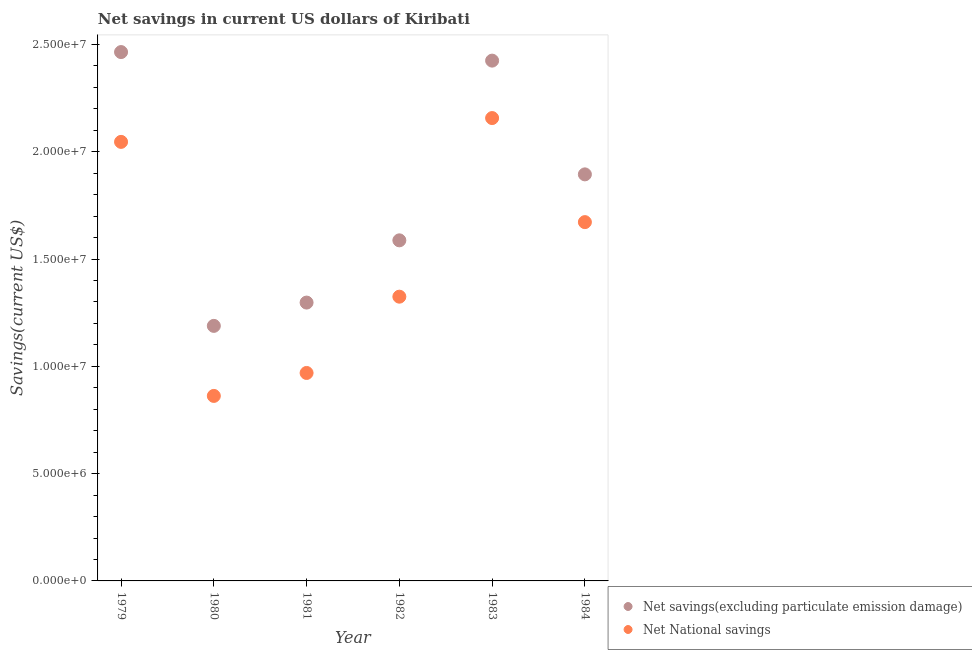What is the net savings(excluding particulate emission damage) in 1981?
Ensure brevity in your answer.  1.30e+07. Across all years, what is the maximum net national savings?
Your answer should be compact. 2.16e+07. Across all years, what is the minimum net national savings?
Ensure brevity in your answer.  8.62e+06. In which year was the net savings(excluding particulate emission damage) maximum?
Your answer should be compact. 1979. In which year was the net savings(excluding particulate emission damage) minimum?
Provide a short and direct response. 1980. What is the total net national savings in the graph?
Keep it short and to the point. 9.03e+07. What is the difference between the net national savings in 1980 and that in 1983?
Keep it short and to the point. -1.29e+07. What is the difference between the net national savings in 1982 and the net savings(excluding particulate emission damage) in 1979?
Ensure brevity in your answer.  -1.14e+07. What is the average net national savings per year?
Give a very brief answer. 1.51e+07. In the year 1982, what is the difference between the net national savings and net savings(excluding particulate emission damage)?
Ensure brevity in your answer.  -2.63e+06. In how many years, is the net national savings greater than 8000000 US$?
Your answer should be compact. 6. What is the ratio of the net national savings in 1982 to that in 1984?
Your response must be concise. 0.79. Is the net savings(excluding particulate emission damage) in 1982 less than that in 1983?
Provide a succinct answer. Yes. Is the difference between the net savings(excluding particulate emission damage) in 1979 and 1980 greater than the difference between the net national savings in 1979 and 1980?
Your answer should be very brief. Yes. What is the difference between the highest and the second highest net savings(excluding particulate emission damage)?
Offer a very short reply. 3.99e+05. What is the difference between the highest and the lowest net savings(excluding particulate emission damage)?
Your answer should be compact. 1.28e+07. In how many years, is the net savings(excluding particulate emission damage) greater than the average net savings(excluding particulate emission damage) taken over all years?
Give a very brief answer. 3. Does the net national savings monotonically increase over the years?
Your response must be concise. No. Is the net national savings strictly greater than the net savings(excluding particulate emission damage) over the years?
Offer a very short reply. No. Is the net national savings strictly less than the net savings(excluding particulate emission damage) over the years?
Provide a succinct answer. Yes. How many dotlines are there?
Offer a very short reply. 2. How many years are there in the graph?
Provide a short and direct response. 6. What is the difference between two consecutive major ticks on the Y-axis?
Keep it short and to the point. 5.00e+06. Does the graph contain any zero values?
Ensure brevity in your answer.  No. Where does the legend appear in the graph?
Ensure brevity in your answer.  Bottom right. How many legend labels are there?
Your response must be concise. 2. How are the legend labels stacked?
Provide a short and direct response. Vertical. What is the title of the graph?
Your response must be concise. Net savings in current US dollars of Kiribati. Does "Crop" appear as one of the legend labels in the graph?
Keep it short and to the point. No. What is the label or title of the Y-axis?
Provide a succinct answer. Savings(current US$). What is the Savings(current US$) in Net savings(excluding particulate emission damage) in 1979?
Offer a terse response. 2.46e+07. What is the Savings(current US$) in Net National savings in 1979?
Give a very brief answer. 2.05e+07. What is the Savings(current US$) in Net savings(excluding particulate emission damage) in 1980?
Make the answer very short. 1.19e+07. What is the Savings(current US$) of Net National savings in 1980?
Ensure brevity in your answer.  8.62e+06. What is the Savings(current US$) in Net savings(excluding particulate emission damage) in 1981?
Your answer should be very brief. 1.30e+07. What is the Savings(current US$) of Net National savings in 1981?
Provide a short and direct response. 9.69e+06. What is the Savings(current US$) in Net savings(excluding particulate emission damage) in 1982?
Offer a very short reply. 1.59e+07. What is the Savings(current US$) of Net National savings in 1982?
Ensure brevity in your answer.  1.32e+07. What is the Savings(current US$) of Net savings(excluding particulate emission damage) in 1983?
Offer a very short reply. 2.42e+07. What is the Savings(current US$) in Net National savings in 1983?
Offer a very short reply. 2.16e+07. What is the Savings(current US$) in Net savings(excluding particulate emission damage) in 1984?
Make the answer very short. 1.89e+07. What is the Savings(current US$) in Net National savings in 1984?
Offer a very short reply. 1.67e+07. Across all years, what is the maximum Savings(current US$) of Net savings(excluding particulate emission damage)?
Offer a terse response. 2.46e+07. Across all years, what is the maximum Savings(current US$) of Net National savings?
Provide a succinct answer. 2.16e+07. Across all years, what is the minimum Savings(current US$) of Net savings(excluding particulate emission damage)?
Your answer should be compact. 1.19e+07. Across all years, what is the minimum Savings(current US$) in Net National savings?
Your answer should be very brief. 8.62e+06. What is the total Savings(current US$) in Net savings(excluding particulate emission damage) in the graph?
Offer a terse response. 1.09e+08. What is the total Savings(current US$) of Net National savings in the graph?
Ensure brevity in your answer.  9.03e+07. What is the difference between the Savings(current US$) in Net savings(excluding particulate emission damage) in 1979 and that in 1980?
Your answer should be very brief. 1.28e+07. What is the difference between the Savings(current US$) of Net National savings in 1979 and that in 1980?
Your answer should be compact. 1.18e+07. What is the difference between the Savings(current US$) in Net savings(excluding particulate emission damage) in 1979 and that in 1981?
Offer a very short reply. 1.17e+07. What is the difference between the Savings(current US$) in Net National savings in 1979 and that in 1981?
Ensure brevity in your answer.  1.08e+07. What is the difference between the Savings(current US$) in Net savings(excluding particulate emission damage) in 1979 and that in 1982?
Keep it short and to the point. 8.77e+06. What is the difference between the Savings(current US$) of Net National savings in 1979 and that in 1982?
Your answer should be very brief. 7.21e+06. What is the difference between the Savings(current US$) of Net savings(excluding particulate emission damage) in 1979 and that in 1983?
Make the answer very short. 3.99e+05. What is the difference between the Savings(current US$) in Net National savings in 1979 and that in 1983?
Your answer should be compact. -1.11e+06. What is the difference between the Savings(current US$) in Net savings(excluding particulate emission damage) in 1979 and that in 1984?
Ensure brevity in your answer.  5.70e+06. What is the difference between the Savings(current US$) of Net National savings in 1979 and that in 1984?
Your answer should be compact. 3.74e+06. What is the difference between the Savings(current US$) of Net savings(excluding particulate emission damage) in 1980 and that in 1981?
Make the answer very short. -1.09e+06. What is the difference between the Savings(current US$) of Net National savings in 1980 and that in 1981?
Offer a terse response. -1.07e+06. What is the difference between the Savings(current US$) in Net savings(excluding particulate emission damage) in 1980 and that in 1982?
Give a very brief answer. -3.99e+06. What is the difference between the Savings(current US$) in Net National savings in 1980 and that in 1982?
Your response must be concise. -4.62e+06. What is the difference between the Savings(current US$) in Net savings(excluding particulate emission damage) in 1980 and that in 1983?
Provide a short and direct response. -1.24e+07. What is the difference between the Savings(current US$) in Net National savings in 1980 and that in 1983?
Give a very brief answer. -1.29e+07. What is the difference between the Savings(current US$) in Net savings(excluding particulate emission damage) in 1980 and that in 1984?
Provide a succinct answer. -7.06e+06. What is the difference between the Savings(current US$) in Net National savings in 1980 and that in 1984?
Your answer should be compact. -8.10e+06. What is the difference between the Savings(current US$) in Net savings(excluding particulate emission damage) in 1981 and that in 1982?
Ensure brevity in your answer.  -2.90e+06. What is the difference between the Savings(current US$) of Net National savings in 1981 and that in 1982?
Your answer should be compact. -3.56e+06. What is the difference between the Savings(current US$) of Net savings(excluding particulate emission damage) in 1981 and that in 1983?
Your answer should be compact. -1.13e+07. What is the difference between the Savings(current US$) in Net National savings in 1981 and that in 1983?
Your response must be concise. -1.19e+07. What is the difference between the Savings(current US$) in Net savings(excluding particulate emission damage) in 1981 and that in 1984?
Keep it short and to the point. -5.98e+06. What is the difference between the Savings(current US$) of Net National savings in 1981 and that in 1984?
Offer a terse response. -7.03e+06. What is the difference between the Savings(current US$) of Net savings(excluding particulate emission damage) in 1982 and that in 1983?
Your answer should be compact. -8.38e+06. What is the difference between the Savings(current US$) in Net National savings in 1982 and that in 1983?
Provide a succinct answer. -8.32e+06. What is the difference between the Savings(current US$) of Net savings(excluding particulate emission damage) in 1982 and that in 1984?
Your answer should be very brief. -3.07e+06. What is the difference between the Savings(current US$) in Net National savings in 1982 and that in 1984?
Provide a succinct answer. -3.47e+06. What is the difference between the Savings(current US$) in Net savings(excluding particulate emission damage) in 1983 and that in 1984?
Keep it short and to the point. 5.30e+06. What is the difference between the Savings(current US$) in Net National savings in 1983 and that in 1984?
Offer a very short reply. 4.85e+06. What is the difference between the Savings(current US$) in Net savings(excluding particulate emission damage) in 1979 and the Savings(current US$) in Net National savings in 1980?
Your answer should be very brief. 1.60e+07. What is the difference between the Savings(current US$) of Net savings(excluding particulate emission damage) in 1979 and the Savings(current US$) of Net National savings in 1981?
Your response must be concise. 1.50e+07. What is the difference between the Savings(current US$) of Net savings(excluding particulate emission damage) in 1979 and the Savings(current US$) of Net National savings in 1982?
Keep it short and to the point. 1.14e+07. What is the difference between the Savings(current US$) in Net savings(excluding particulate emission damage) in 1979 and the Savings(current US$) in Net National savings in 1983?
Ensure brevity in your answer.  3.08e+06. What is the difference between the Savings(current US$) in Net savings(excluding particulate emission damage) in 1979 and the Savings(current US$) in Net National savings in 1984?
Your response must be concise. 7.93e+06. What is the difference between the Savings(current US$) in Net savings(excluding particulate emission damage) in 1980 and the Savings(current US$) in Net National savings in 1981?
Ensure brevity in your answer.  2.19e+06. What is the difference between the Savings(current US$) of Net savings(excluding particulate emission damage) in 1980 and the Savings(current US$) of Net National savings in 1982?
Offer a very short reply. -1.36e+06. What is the difference between the Savings(current US$) of Net savings(excluding particulate emission damage) in 1980 and the Savings(current US$) of Net National savings in 1983?
Ensure brevity in your answer.  -9.68e+06. What is the difference between the Savings(current US$) in Net savings(excluding particulate emission damage) in 1980 and the Savings(current US$) in Net National savings in 1984?
Your answer should be very brief. -4.84e+06. What is the difference between the Savings(current US$) of Net savings(excluding particulate emission damage) in 1981 and the Savings(current US$) of Net National savings in 1982?
Give a very brief answer. -2.75e+05. What is the difference between the Savings(current US$) of Net savings(excluding particulate emission damage) in 1981 and the Savings(current US$) of Net National savings in 1983?
Offer a very short reply. -8.60e+06. What is the difference between the Savings(current US$) in Net savings(excluding particulate emission damage) in 1981 and the Savings(current US$) in Net National savings in 1984?
Offer a terse response. -3.75e+06. What is the difference between the Savings(current US$) of Net savings(excluding particulate emission damage) in 1982 and the Savings(current US$) of Net National savings in 1983?
Your answer should be very brief. -5.70e+06. What is the difference between the Savings(current US$) in Net savings(excluding particulate emission damage) in 1982 and the Savings(current US$) in Net National savings in 1984?
Your answer should be compact. -8.49e+05. What is the difference between the Savings(current US$) of Net savings(excluding particulate emission damage) in 1983 and the Savings(current US$) of Net National savings in 1984?
Offer a terse response. 7.53e+06. What is the average Savings(current US$) in Net savings(excluding particulate emission damage) per year?
Give a very brief answer. 1.81e+07. What is the average Savings(current US$) in Net National savings per year?
Provide a succinct answer. 1.51e+07. In the year 1979, what is the difference between the Savings(current US$) of Net savings(excluding particulate emission damage) and Savings(current US$) of Net National savings?
Provide a succinct answer. 4.19e+06. In the year 1980, what is the difference between the Savings(current US$) in Net savings(excluding particulate emission damage) and Savings(current US$) in Net National savings?
Keep it short and to the point. 3.26e+06. In the year 1981, what is the difference between the Savings(current US$) of Net savings(excluding particulate emission damage) and Savings(current US$) of Net National savings?
Provide a short and direct response. 3.28e+06. In the year 1982, what is the difference between the Savings(current US$) of Net savings(excluding particulate emission damage) and Savings(current US$) of Net National savings?
Your response must be concise. 2.63e+06. In the year 1983, what is the difference between the Savings(current US$) in Net savings(excluding particulate emission damage) and Savings(current US$) in Net National savings?
Your answer should be very brief. 2.68e+06. In the year 1984, what is the difference between the Savings(current US$) of Net savings(excluding particulate emission damage) and Savings(current US$) of Net National savings?
Give a very brief answer. 2.23e+06. What is the ratio of the Savings(current US$) of Net savings(excluding particulate emission damage) in 1979 to that in 1980?
Ensure brevity in your answer.  2.07. What is the ratio of the Savings(current US$) in Net National savings in 1979 to that in 1980?
Give a very brief answer. 2.37. What is the ratio of the Savings(current US$) of Net savings(excluding particulate emission damage) in 1979 to that in 1981?
Ensure brevity in your answer.  1.9. What is the ratio of the Savings(current US$) in Net National savings in 1979 to that in 1981?
Make the answer very short. 2.11. What is the ratio of the Savings(current US$) of Net savings(excluding particulate emission damage) in 1979 to that in 1982?
Your response must be concise. 1.55. What is the ratio of the Savings(current US$) in Net National savings in 1979 to that in 1982?
Your answer should be very brief. 1.54. What is the ratio of the Savings(current US$) of Net savings(excluding particulate emission damage) in 1979 to that in 1983?
Provide a short and direct response. 1.02. What is the ratio of the Savings(current US$) in Net National savings in 1979 to that in 1983?
Give a very brief answer. 0.95. What is the ratio of the Savings(current US$) in Net savings(excluding particulate emission damage) in 1979 to that in 1984?
Keep it short and to the point. 1.3. What is the ratio of the Savings(current US$) in Net National savings in 1979 to that in 1984?
Ensure brevity in your answer.  1.22. What is the ratio of the Savings(current US$) of Net savings(excluding particulate emission damage) in 1980 to that in 1981?
Ensure brevity in your answer.  0.92. What is the ratio of the Savings(current US$) of Net National savings in 1980 to that in 1981?
Provide a short and direct response. 0.89. What is the ratio of the Savings(current US$) of Net savings(excluding particulate emission damage) in 1980 to that in 1982?
Offer a very short reply. 0.75. What is the ratio of the Savings(current US$) of Net National savings in 1980 to that in 1982?
Keep it short and to the point. 0.65. What is the ratio of the Savings(current US$) of Net savings(excluding particulate emission damage) in 1980 to that in 1983?
Offer a terse response. 0.49. What is the ratio of the Savings(current US$) in Net National savings in 1980 to that in 1983?
Make the answer very short. 0.4. What is the ratio of the Savings(current US$) of Net savings(excluding particulate emission damage) in 1980 to that in 1984?
Provide a succinct answer. 0.63. What is the ratio of the Savings(current US$) of Net National savings in 1980 to that in 1984?
Your answer should be very brief. 0.52. What is the ratio of the Savings(current US$) of Net savings(excluding particulate emission damage) in 1981 to that in 1982?
Make the answer very short. 0.82. What is the ratio of the Savings(current US$) in Net National savings in 1981 to that in 1982?
Offer a very short reply. 0.73. What is the ratio of the Savings(current US$) in Net savings(excluding particulate emission damage) in 1981 to that in 1983?
Keep it short and to the point. 0.54. What is the ratio of the Savings(current US$) of Net National savings in 1981 to that in 1983?
Make the answer very short. 0.45. What is the ratio of the Savings(current US$) of Net savings(excluding particulate emission damage) in 1981 to that in 1984?
Offer a very short reply. 0.68. What is the ratio of the Savings(current US$) of Net National savings in 1981 to that in 1984?
Give a very brief answer. 0.58. What is the ratio of the Savings(current US$) of Net savings(excluding particulate emission damage) in 1982 to that in 1983?
Provide a succinct answer. 0.65. What is the ratio of the Savings(current US$) of Net National savings in 1982 to that in 1983?
Provide a short and direct response. 0.61. What is the ratio of the Savings(current US$) in Net savings(excluding particulate emission damage) in 1982 to that in 1984?
Make the answer very short. 0.84. What is the ratio of the Savings(current US$) of Net National savings in 1982 to that in 1984?
Provide a succinct answer. 0.79. What is the ratio of the Savings(current US$) of Net savings(excluding particulate emission damage) in 1983 to that in 1984?
Your answer should be compact. 1.28. What is the ratio of the Savings(current US$) in Net National savings in 1983 to that in 1984?
Give a very brief answer. 1.29. What is the difference between the highest and the second highest Savings(current US$) of Net savings(excluding particulate emission damage)?
Make the answer very short. 3.99e+05. What is the difference between the highest and the second highest Savings(current US$) in Net National savings?
Make the answer very short. 1.11e+06. What is the difference between the highest and the lowest Savings(current US$) in Net savings(excluding particulate emission damage)?
Make the answer very short. 1.28e+07. What is the difference between the highest and the lowest Savings(current US$) of Net National savings?
Ensure brevity in your answer.  1.29e+07. 